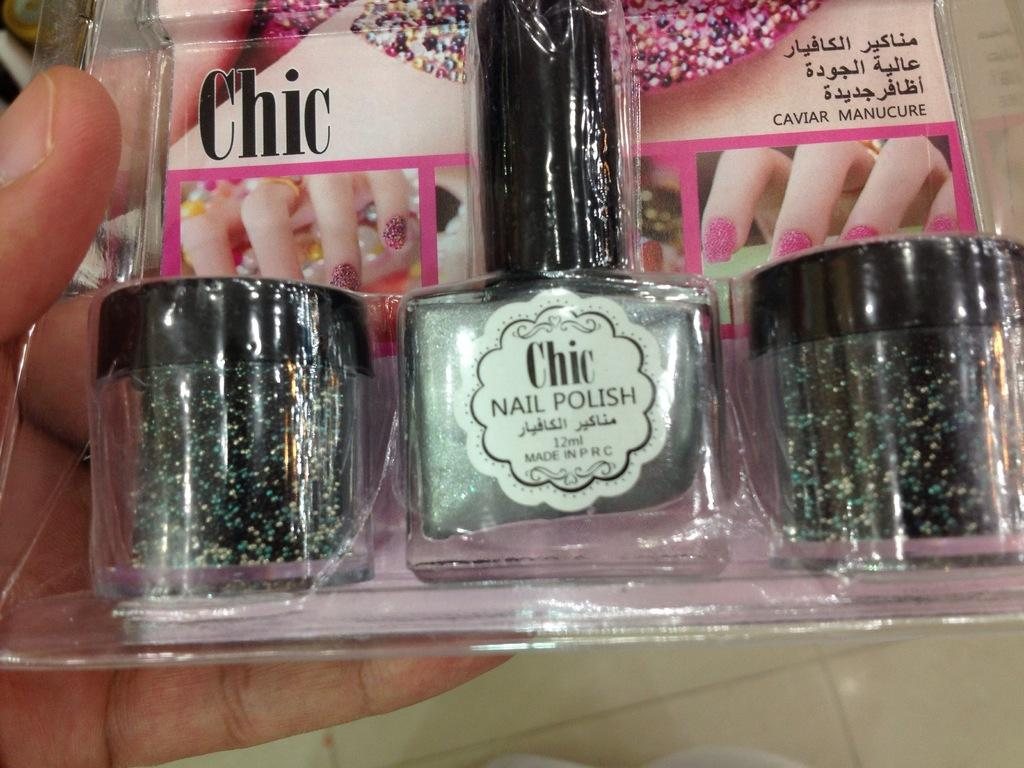<image>
Render a clear and concise summary of the photo. Chic nail polish in a box next to some glitter. 